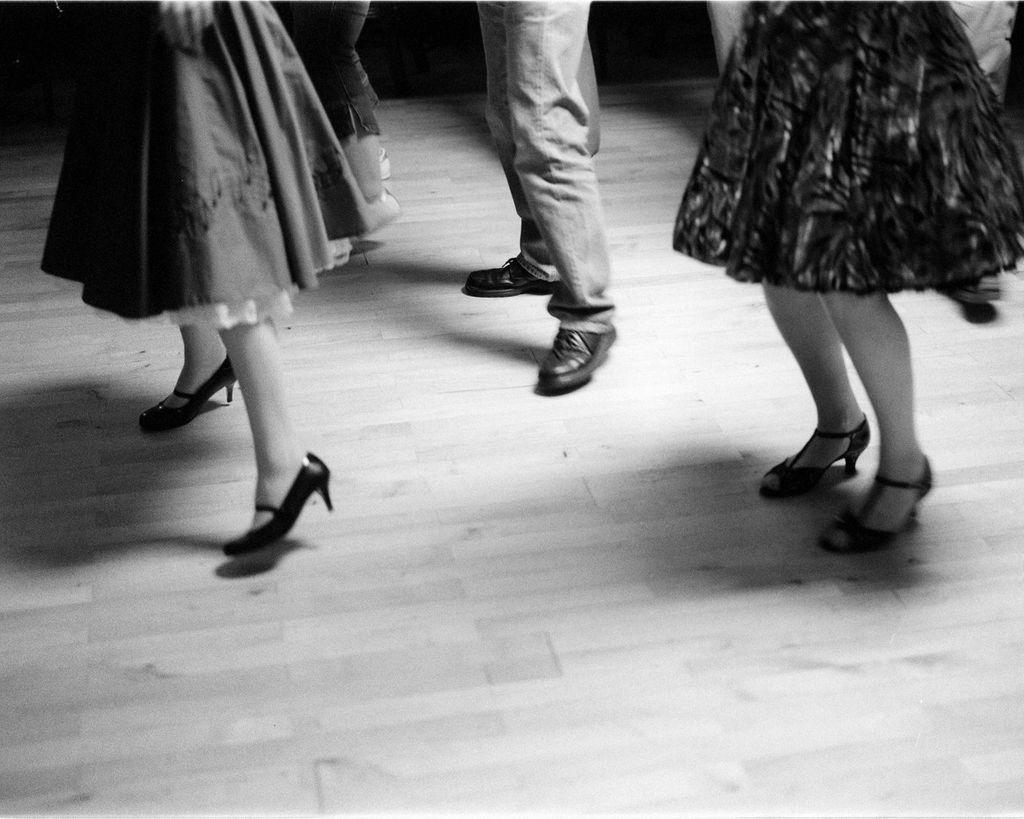What is the color scheme of the image? The image is black and white. What can be seen within the image? There is a picture within the image. What is depicted in the picture? The picture contains the legs of three persons. Where are the legs positioned in the image? The legs are standing on the floor. What type of hat is being worn by the person in the image? There is no person or hat visible in the image; it only contains the legs of three persons standing on the floor. 